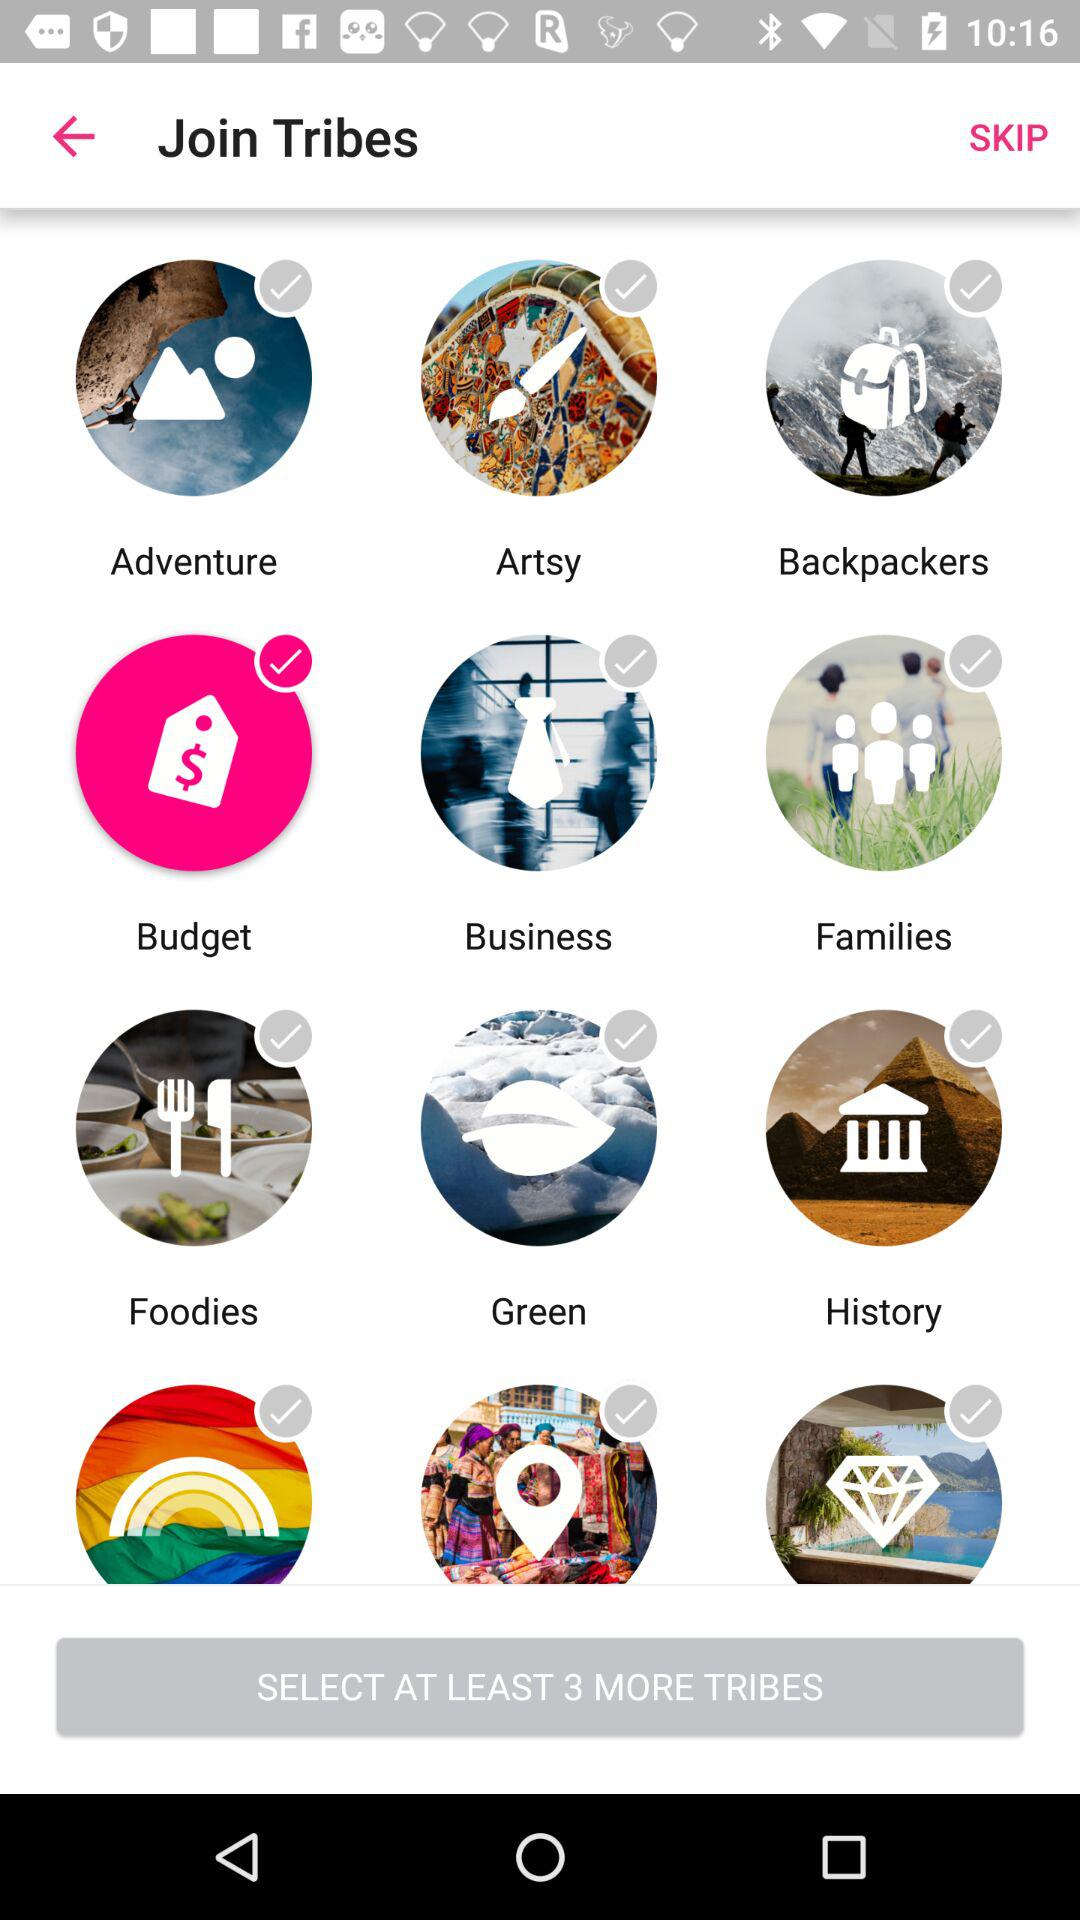How many more tribes have to be selected? The number of tribes that have to be selected is at least 3. 